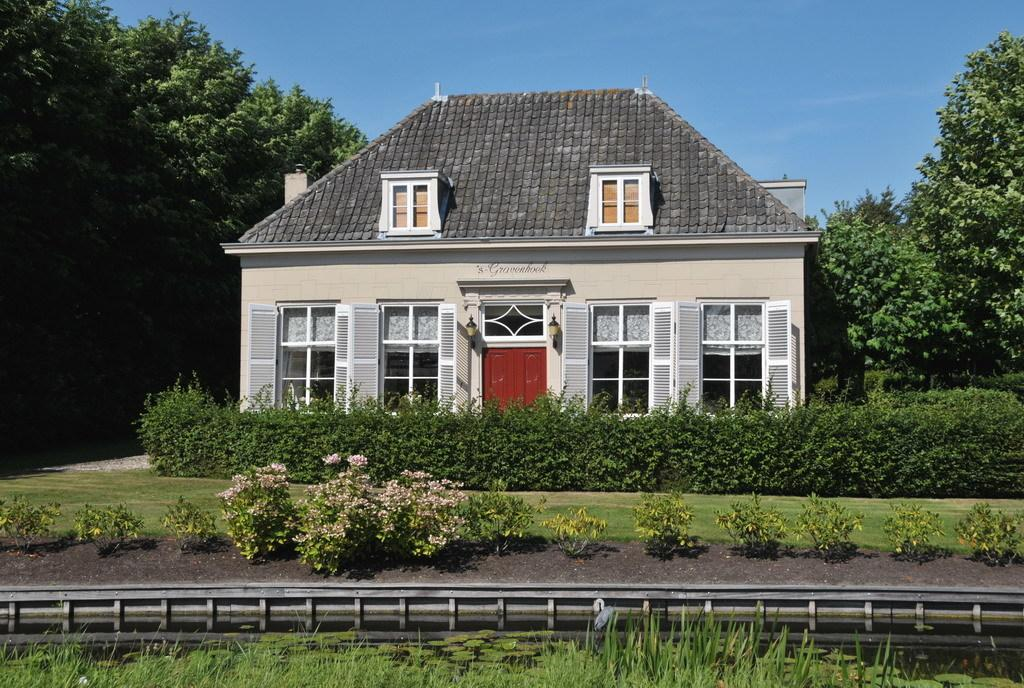What is the main structure in the center of the image? There is a house in the center of the image. What type of vegetation can be seen on the right side of the image? There are trees on the right side of the image. What type of vegetation can be seen on the left side of the image? There are trees on the left side of the image. What type of terrain is visible at the bottom side of the image? There is grassland at the bottom side of the image. What type of gate is present in the image? There is no gate present in the image. What subject is being taught in the image? There is no teaching or educational activity depicted in the image. 